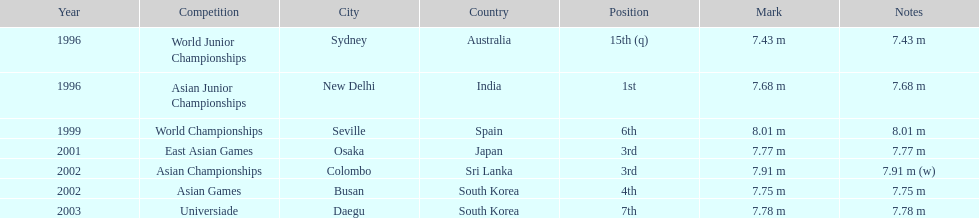What was the only competition where this competitor achieved 1st place? Asian Junior Championships. 